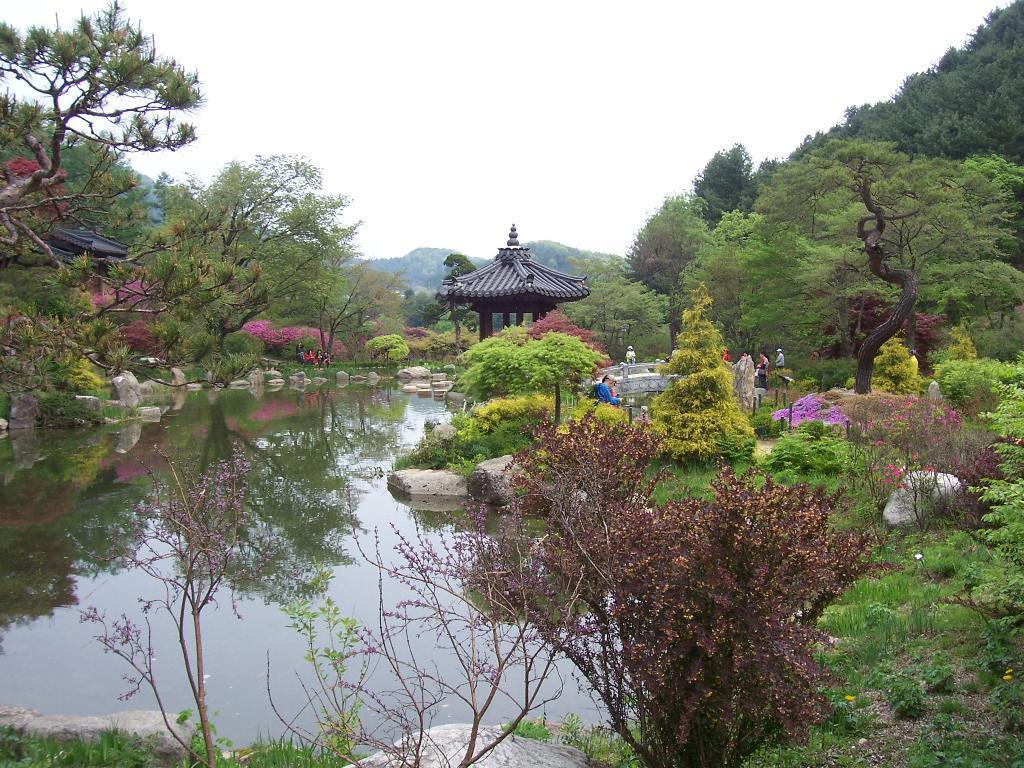Could you give a brief overview of what you see in this image? On the right side of the picture, we see trees and grass. At the bottom of the picture, we see water and stones. This water might be in the pond. In the middle of the picture, we see a Chinese architecture. Beside that, we see people are standing. There are trees in the background. At the top of the picture, we see the sky. 